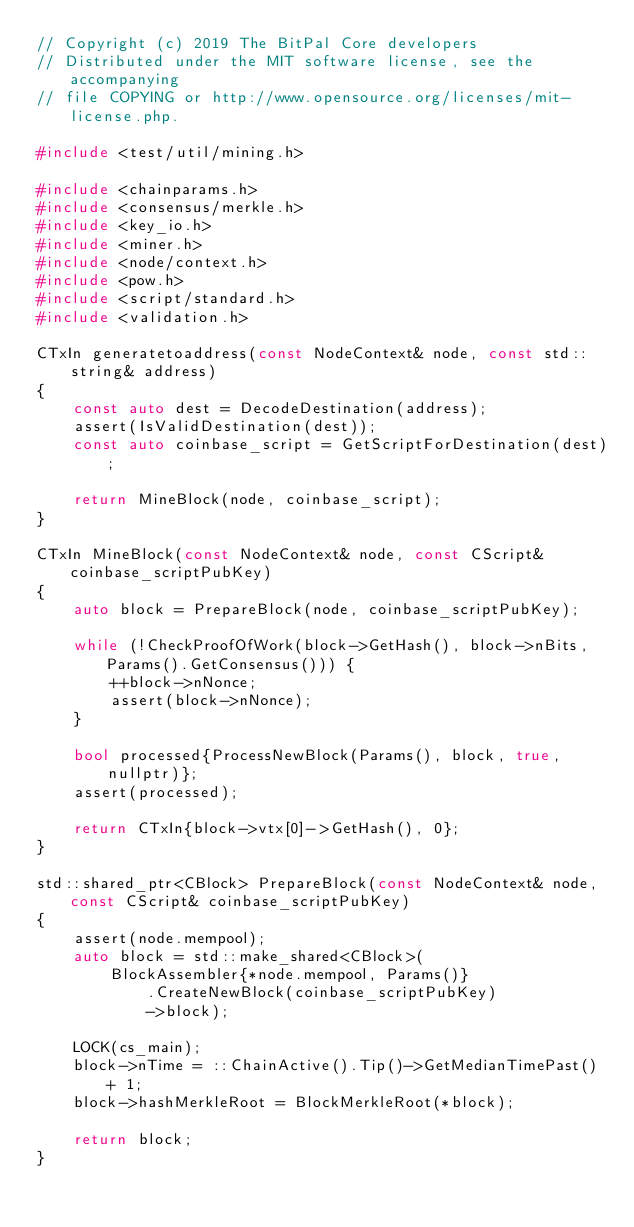Convert code to text. <code><loc_0><loc_0><loc_500><loc_500><_C++_>// Copyright (c) 2019 The BitPal Core developers
// Distributed under the MIT software license, see the accompanying
// file COPYING or http://www.opensource.org/licenses/mit-license.php.

#include <test/util/mining.h>

#include <chainparams.h>
#include <consensus/merkle.h>
#include <key_io.h>
#include <miner.h>
#include <node/context.h>
#include <pow.h>
#include <script/standard.h>
#include <validation.h>

CTxIn generatetoaddress(const NodeContext& node, const std::string& address)
{
    const auto dest = DecodeDestination(address);
    assert(IsValidDestination(dest));
    const auto coinbase_script = GetScriptForDestination(dest);

    return MineBlock(node, coinbase_script);
}

CTxIn MineBlock(const NodeContext& node, const CScript& coinbase_scriptPubKey)
{
    auto block = PrepareBlock(node, coinbase_scriptPubKey);

    while (!CheckProofOfWork(block->GetHash(), block->nBits, Params().GetConsensus())) {
        ++block->nNonce;
        assert(block->nNonce);
    }

    bool processed{ProcessNewBlock(Params(), block, true, nullptr)};
    assert(processed);

    return CTxIn{block->vtx[0]->GetHash(), 0};
}

std::shared_ptr<CBlock> PrepareBlock(const NodeContext& node, const CScript& coinbase_scriptPubKey)
{
    assert(node.mempool);
    auto block = std::make_shared<CBlock>(
        BlockAssembler{*node.mempool, Params()}
            .CreateNewBlock(coinbase_scriptPubKey)
            ->block);

    LOCK(cs_main);
    block->nTime = ::ChainActive().Tip()->GetMedianTimePast() + 1;
    block->hashMerkleRoot = BlockMerkleRoot(*block);

    return block;
}
</code> 